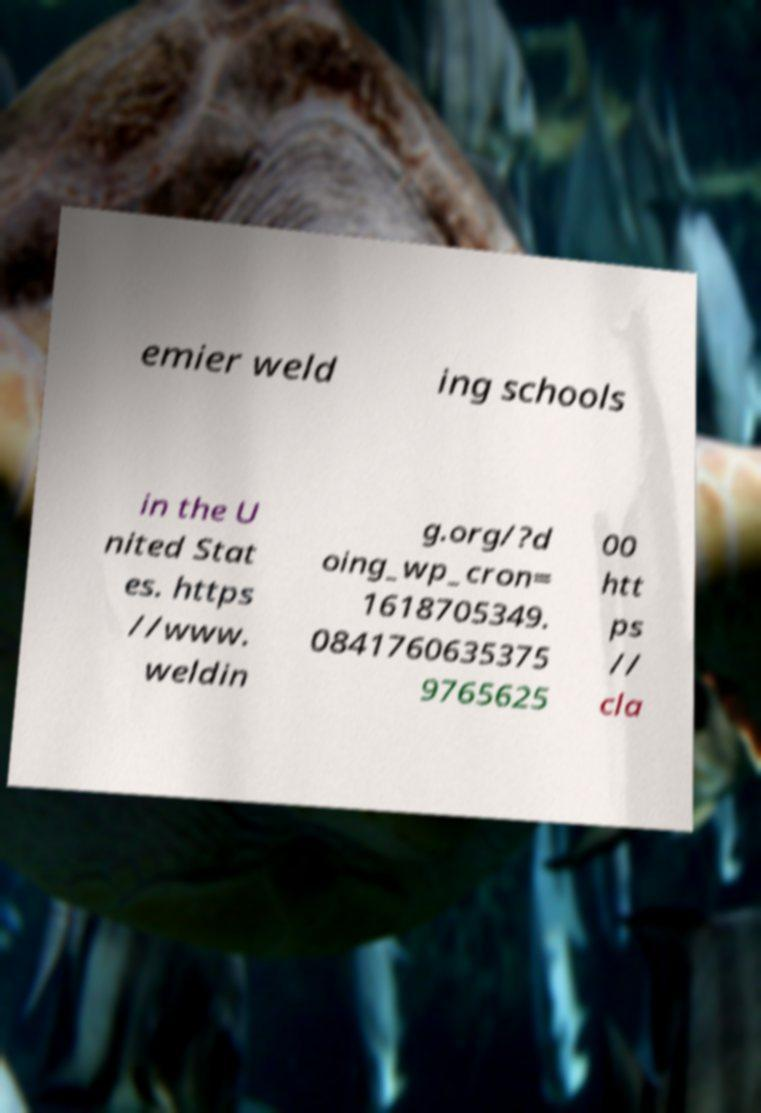Could you extract and type out the text from this image? emier weld ing schools in the U nited Stat es. https //www. weldin g.org/?d oing_wp_cron= 1618705349. 0841760635375 9765625 00 htt ps // cla 